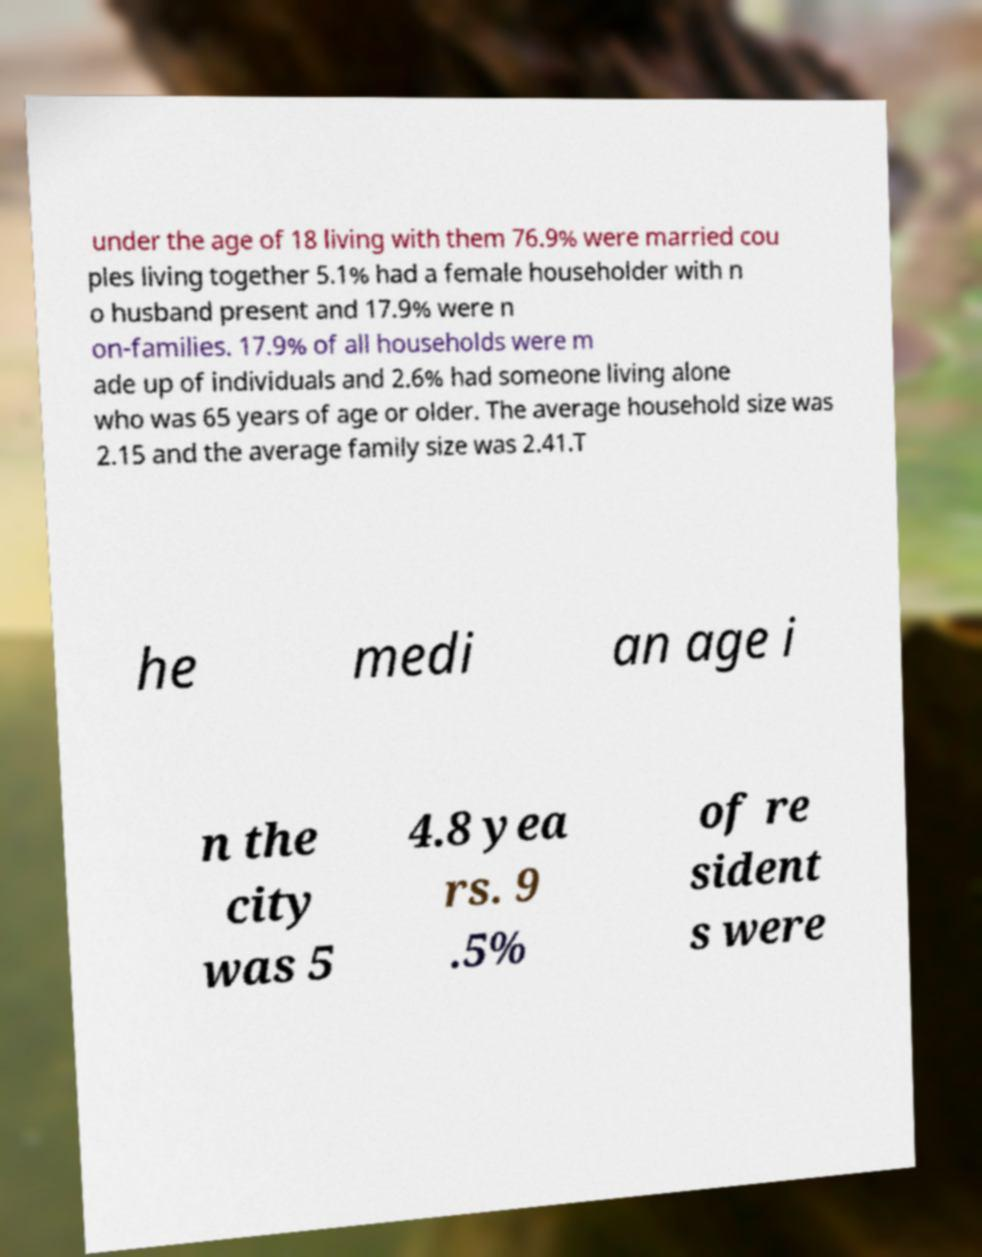Could you extract and type out the text from this image? under the age of 18 living with them 76.9% were married cou ples living together 5.1% had a female householder with n o husband present and 17.9% were n on-families. 17.9% of all households were m ade up of individuals and 2.6% had someone living alone who was 65 years of age or older. The average household size was 2.15 and the average family size was 2.41.T he medi an age i n the city was 5 4.8 yea rs. 9 .5% of re sident s were 